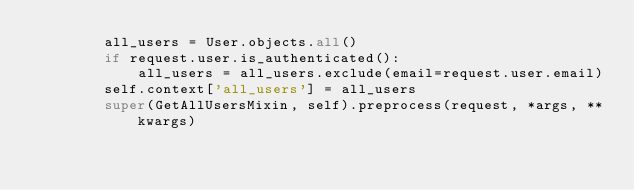<code> <loc_0><loc_0><loc_500><loc_500><_Python_>        all_users = User.objects.all()
        if request.user.is_authenticated():
            all_users = all_users.exclude(email=request.user.email)
        self.context['all_users'] = all_users
        super(GetAllUsersMixin, self).preprocess(request, *args, **kwargs)
</code> 